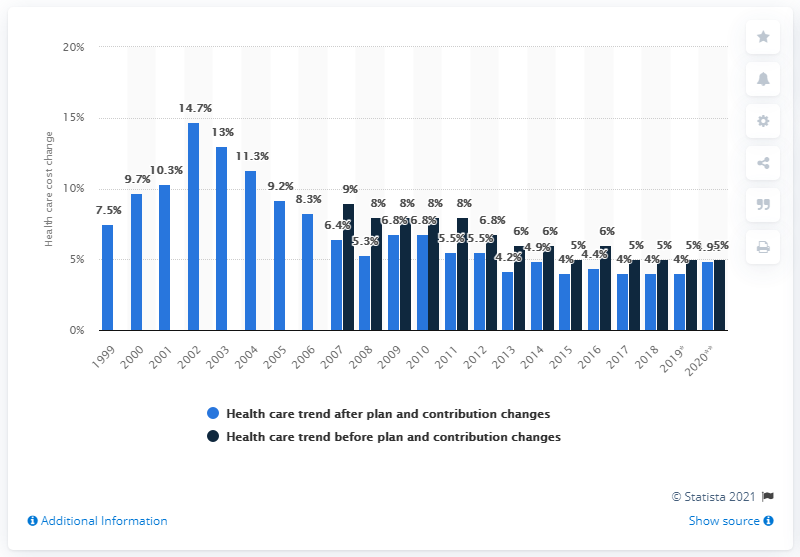List a handful of essential elements in this visual. The projected increase in health care costs for employers in 2020 is expected to be 4.9%. 